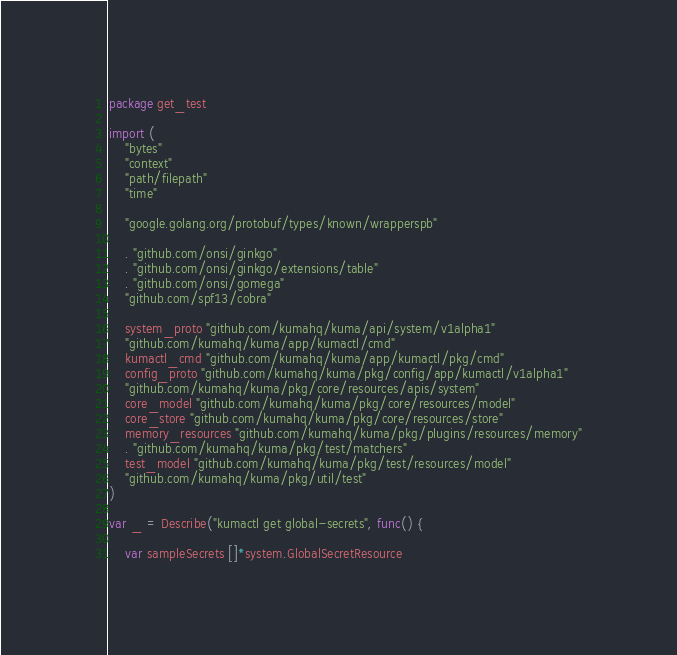Convert code to text. <code><loc_0><loc_0><loc_500><loc_500><_Go_>package get_test

import (
	"bytes"
	"context"
	"path/filepath"
	"time"

	"google.golang.org/protobuf/types/known/wrapperspb"

	. "github.com/onsi/ginkgo"
	. "github.com/onsi/ginkgo/extensions/table"
	. "github.com/onsi/gomega"
	"github.com/spf13/cobra"

	system_proto "github.com/kumahq/kuma/api/system/v1alpha1"
	"github.com/kumahq/kuma/app/kumactl/cmd"
	kumactl_cmd "github.com/kumahq/kuma/app/kumactl/pkg/cmd"
	config_proto "github.com/kumahq/kuma/pkg/config/app/kumactl/v1alpha1"
	"github.com/kumahq/kuma/pkg/core/resources/apis/system"
	core_model "github.com/kumahq/kuma/pkg/core/resources/model"
	core_store "github.com/kumahq/kuma/pkg/core/resources/store"
	memory_resources "github.com/kumahq/kuma/pkg/plugins/resources/memory"
	. "github.com/kumahq/kuma/pkg/test/matchers"
	test_model "github.com/kumahq/kuma/pkg/test/resources/model"
	"github.com/kumahq/kuma/pkg/util/test"
)

var _ = Describe("kumactl get global-secrets", func() {

	var sampleSecrets []*system.GlobalSecretResource
</code> 